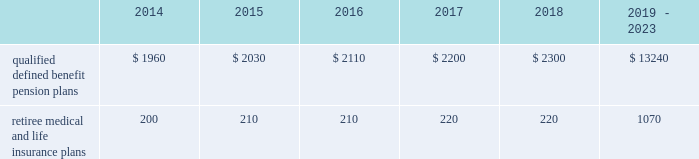Valuation techniques 2013 cash equivalents are mostly comprised of short-term money-market instruments and are valued at cost , which approximates fair value .
U.s .
Equity securities and international equity securities categorized as level 1 are traded on active national and international exchanges and are valued at their closing prices on the last trading day of the year .
For u.s .
Equity securities and international equity securities not traded on an active exchange , or if the closing price is not available , the trustee obtains indicative quotes from a pricing vendor , broker , or investment manager .
These securities are categorized as level 2 if the custodian obtains corroborated quotes from a pricing vendor or categorized as level 3 if the custodian obtains uncorroborated quotes from a broker or investment manager .
Commingled equity funds are investment vehicles valued using the net asset value ( nav ) provided by the fund managers .
The nav is the total value of the fund divided by the number of shares outstanding .
Commingled equity funds are categorized as level 1 if traded at their nav on a nationally recognized securities exchange or categorized as level 2 if the nav is corroborated by observable market data ( e.g. , purchases or sales activity ) and we are able to redeem our investment in the near-term .
Fixed income investments categorized as level 2 are valued by the trustee using pricing models that use verifiable observable market data ( e.g. , interest rates and yield curves observable at commonly quoted intervals and credit spreads ) , bids provided by brokers or dealers , or quoted prices of securities with similar characteristics .
Fixed income investments are categorized at level 3 when valuations using observable inputs are unavailable .
The trustee obtains pricing based on indicative quotes or bid evaluations from vendors , brokers , or the investment manager .
Private equity funds , real estate funds , and hedge funds are valued using the nav based on valuation models of underlying securities which generally include significant unobservable inputs that cannot be corroborated using verifiable observable market data .
Valuations for private equity funds and real estate funds are determined by the general partners .
Depending on the nature of the assets , the general partners may use various valuation methodologies , including the income and market approaches in their models .
The market approach consists of analyzing market transactions for comparable assets while the income approach uses earnings or the net present value of estimated future cash flows adjusted for liquidity and other risk factors .
Hedge funds are valued by independent administrators using various pricing sources and models based on the nature of the securities .
Private equity funds , real estate funds , and hedge funds are generally categorized as level 3 as we cannot fully redeem our investment in the near-term .
Commodities are traded on an active commodity exchange and are valued at their closing prices on the last trading day of the year .
Contributions and expected benefit payments we generally determine funding requirements for our defined benefit pension plans in a manner consistent with cas and internal revenue code rules .
In 2013 , we made contributions of $ 2.25 billion related to our qualified defined benefit pension plans .
We currently plan to make contributions of approximately $ 1.0 billion related to the qualified defined benefit pension plans in 2014 .
In 2013 , we made contributions of $ 98 million to our retiree medical and life insurance plans .
We do not expect to make contributions related to the retiree medical and life insurance plans in 2014 as a result of our 2013 contributions .
The table presents estimated future benefit payments , which reflect expected future employee service , as of december 31 , 2013 ( in millions ) : .
Defined contribution plans we maintain a number of defined contribution plans , most with 401 ( k ) features , that cover substantially all of our employees .
Under the provisions of our 401 ( k ) plans , we match most employees 2019 eligible contributions at rates specified in the plan documents .
Our contributions were $ 383 million in 2013 , $ 380 million in 2012 , and $ 378 million in 2011 , the majority of which were funded in our common stock .
Our defined contribution plans held approximately 44.7 million and 48.6 million shares of our common stock as of december 31 , 2013 and 2012. .
What is the change in estimated future benefit payments , which reflect expected future employee service , as of december 31 , 2013 , from 2015 to 2016 in millions? 
Computations: (2110 - 2030)
Answer: 80.0. 